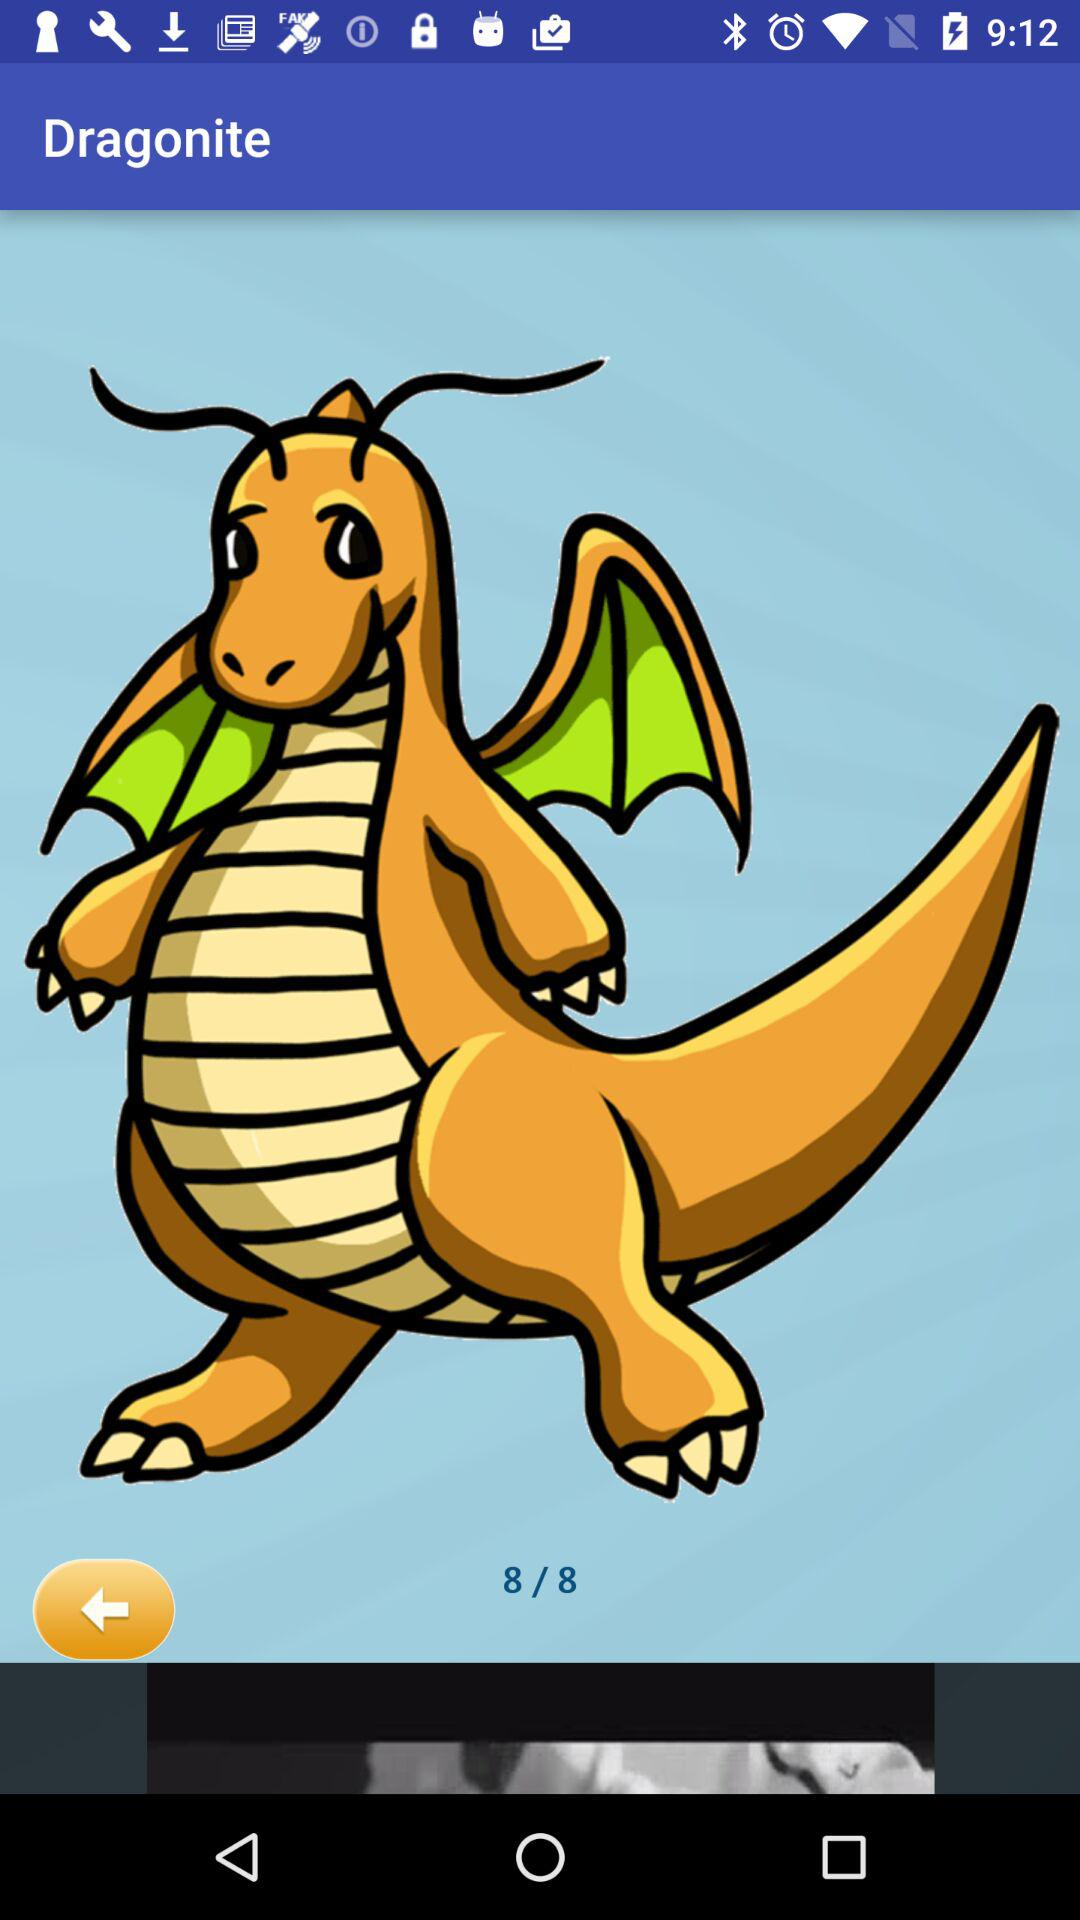How many sets are available? There are 8 sets available. 